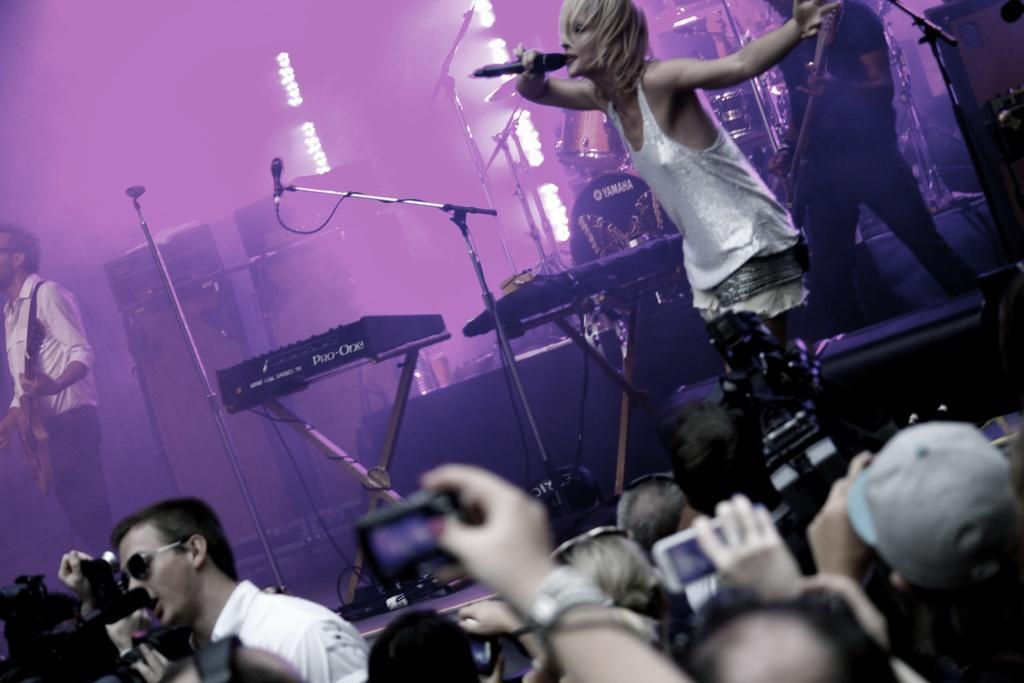Could you give a brief overview of what you see in this image? In this picture there are people as audience at the bottom side of the image and there is a stage in the center of the image, there is a girl on the stage, on the right side of the image, by holding a mic in her hand, there is another boy who is standing on the left side of the image, he is playing the guitar and there are musical instruments on the stage. 